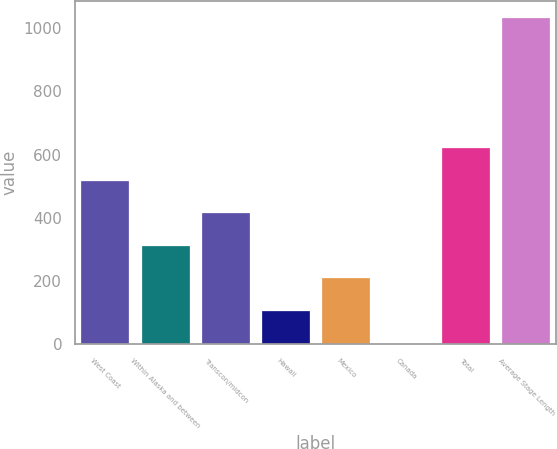Convert chart to OTSL. <chart><loc_0><loc_0><loc_500><loc_500><bar_chart><fcel>West Coast<fcel>Within Alaska and between<fcel>Transcon/midcon<fcel>Hawaii<fcel>Mexico<fcel>Canada<fcel>Total<fcel>Average Stage Length<nl><fcel>518<fcel>311.6<fcel>414.8<fcel>105.2<fcel>208.4<fcel>2<fcel>621.2<fcel>1034<nl></chart> 